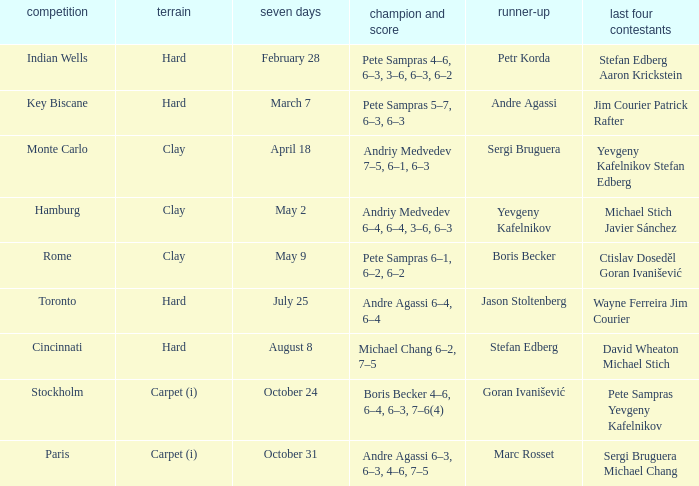Who was the semifinalist for the key biscane tournament? Jim Courier Patrick Rafter. 